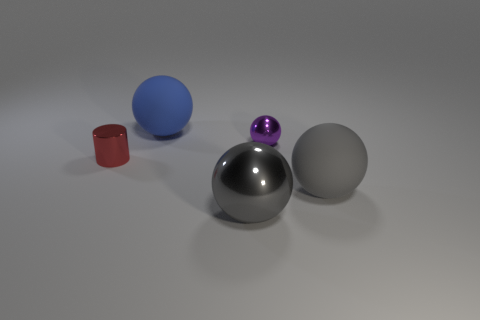What shape is the object that is both behind the tiny red object and on the left side of the small purple metal sphere?
Offer a very short reply. Sphere. How many other things are the same color as the large metallic ball?
Your answer should be compact. 1. The gray matte object has what shape?
Provide a short and direct response. Sphere. There is a matte sphere behind the small metal object on the left side of the big metal ball; what is its color?
Keep it short and to the point. Blue. There is a big shiny thing; is its color the same as the big rubber ball right of the large shiny thing?
Offer a very short reply. Yes. There is a object that is both behind the tiny red metal thing and right of the big shiny thing; what material is it?
Keep it short and to the point. Metal. Is there a red object of the same size as the purple sphere?
Provide a succinct answer. Yes. There is another gray thing that is the same size as the gray rubber object; what is its material?
Give a very brief answer. Metal. What number of small red metal cylinders are to the right of the purple metal object?
Ensure brevity in your answer.  0. Does the object that is right of the tiny purple object have the same shape as the large blue object?
Provide a succinct answer. Yes. 